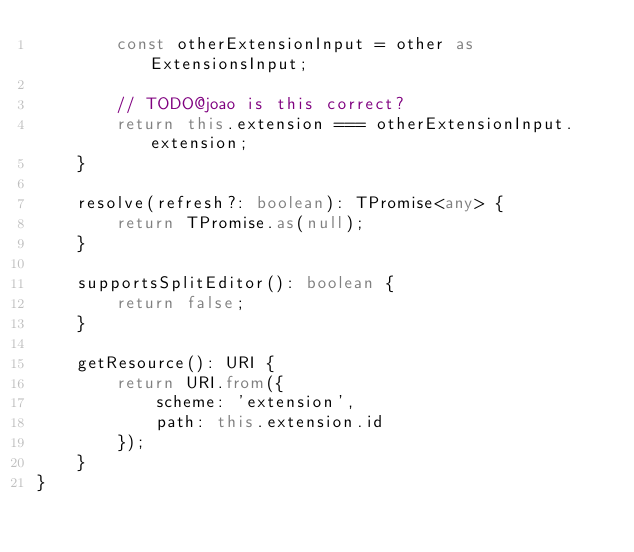Convert code to text. <code><loc_0><loc_0><loc_500><loc_500><_TypeScript_>		const otherExtensionInput = other as ExtensionsInput;

		// TODO@joao is this correct?
		return this.extension === otherExtensionInput.extension;
	}

	resolve(refresh?: boolean): TPromise<any> {
		return TPromise.as(null);
	}

	supportsSplitEditor(): boolean {
		return false;
	}

	getResource(): URI {
		return URI.from({
			scheme: 'extension',
			path: this.extension.id
		});
	}
}</code> 